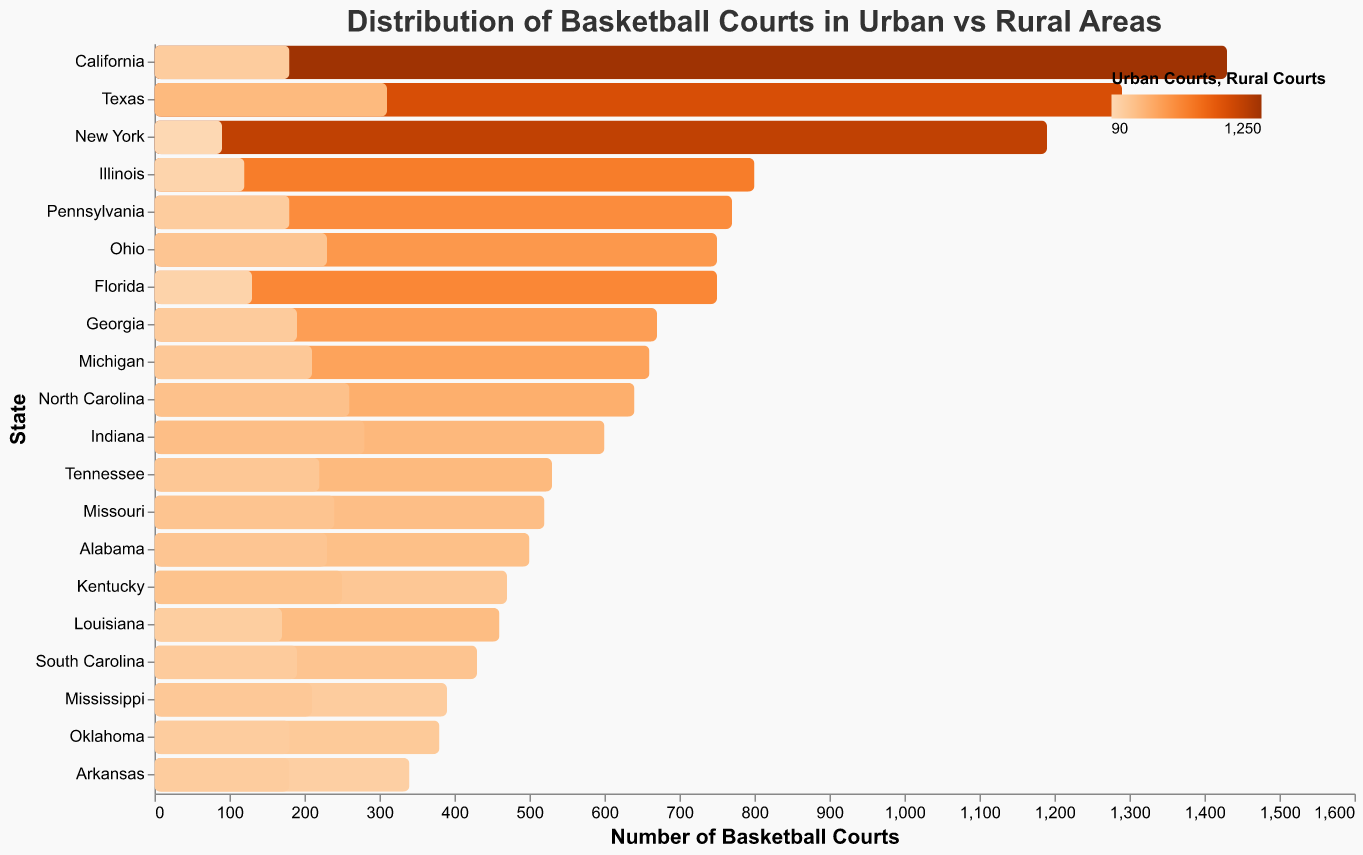Which state has the highest number of total basketball courts? To determine the state with the highest total number of basketball courts, look for the state with the largest value in the 'Total_Courts' category in the chart. California has the highest total with 1430 courts.
Answer: California Which state has more rural courts than urban courts? Identify the states where the number of rural courts is greater than urban courts by comparing 'Urban_Courts' and 'Rural_Courts' values. Indiana (280 rural vs 320 urban) and Kentucky (250 rural vs 220 urban) have more rural courts.
Answer: Indiana, Kentucky Which state has the smallest difference between urban and rural basketball courts? Calculate the difference between urban and rural courts for each state, then find the state with the smallest absolute difference. Arkansas has the smallest difference with 160 urban courts and 180 rural courts, resulting in a difference of 20.
Answer: Arkansas What is the ratio of urban to rural courts in New York? The number of urban courts in New York is 1100, and the number of rural courts is 90. The ratio is calculated by dividing the count of urban courts by rural courts: 1100 / 90 ≈ 12.22.
Answer: 12.22 Which states have urban basketball courts with a number over 600? Look for states where the number of 'Urban_Courts' exceeds 600. California (1250), Texas (980), New York (1100), and Florida (620) all meet this criterion.
Answer: California, Texas, New York, Florida What is the total number of basketball courts in the top three states? Identify the top three states with the highest number of total courts and sum their values. California (1430), Texas (1290), and New York (1190) have the most, and their total is 1430 + 1290 + 1190 = 3910.
Answer: 3910 Between Ohio and Georgia, which state has a higher total number of basketball courts? Compare the 'Total_Courts' values for Ohio (750) and Georgia (670). Ohio has more total basketball courts.
Answer: Ohio How many states have over 500 total basketball courts? Count the number of states where the 'Total_Courts' value is greater than 500. The states with over 500 courts are California, Texas, New York, Illinois, Pennsylvania, Ohio, Georgia, Florida, North Carolina, Indiana, Tennessee, and Missouri, which makes 12 states.
Answer: 12 Which state has more rural basketball courts, Texas or Missouri? Compare the 'Rural_Courts' values of Texas (310) and Missouri (240). Texas has more rural basketball courts.
Answer: Texas 